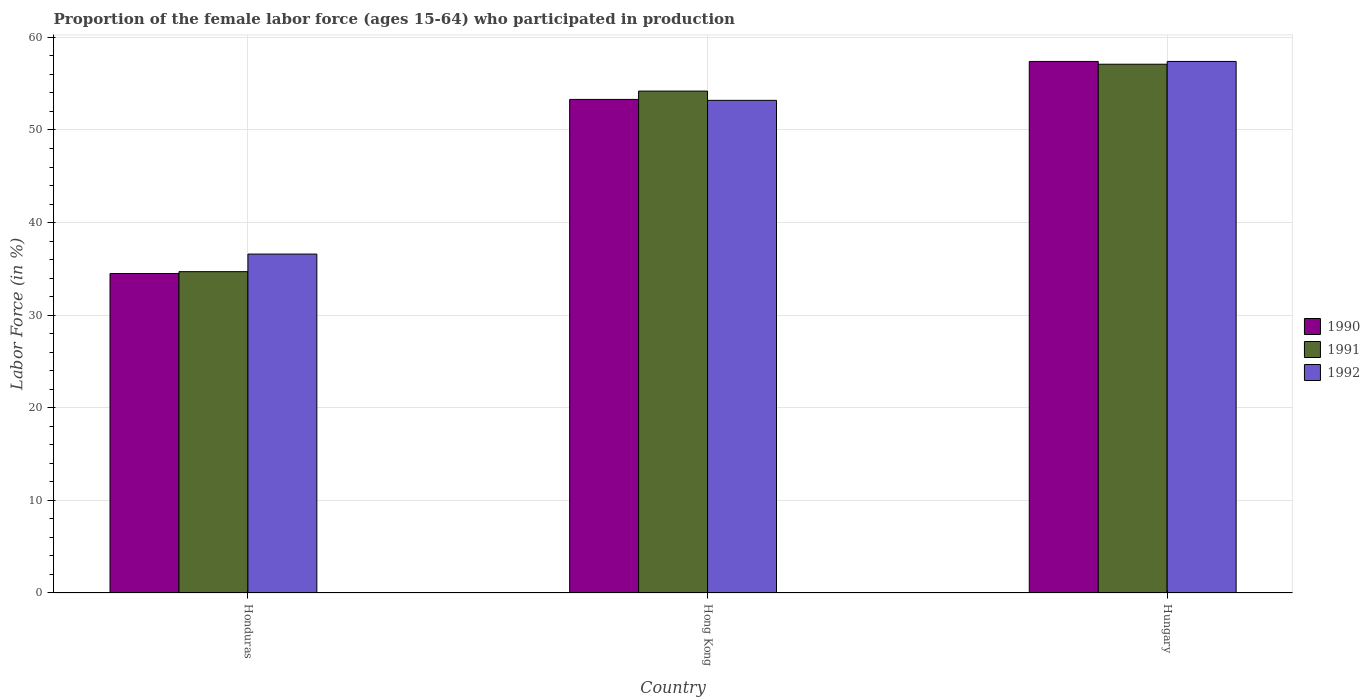How many different coloured bars are there?
Your answer should be very brief. 3. How many groups of bars are there?
Provide a succinct answer. 3. Are the number of bars per tick equal to the number of legend labels?
Your response must be concise. Yes. Are the number of bars on each tick of the X-axis equal?
Ensure brevity in your answer.  Yes. What is the label of the 3rd group of bars from the left?
Keep it short and to the point. Hungary. In how many cases, is the number of bars for a given country not equal to the number of legend labels?
Keep it short and to the point. 0. What is the proportion of the female labor force who participated in production in 1991 in Hong Kong?
Provide a succinct answer. 54.2. Across all countries, what is the maximum proportion of the female labor force who participated in production in 1990?
Offer a very short reply. 57.4. Across all countries, what is the minimum proportion of the female labor force who participated in production in 1992?
Your answer should be very brief. 36.6. In which country was the proportion of the female labor force who participated in production in 1992 maximum?
Make the answer very short. Hungary. In which country was the proportion of the female labor force who participated in production in 1990 minimum?
Make the answer very short. Honduras. What is the total proportion of the female labor force who participated in production in 1990 in the graph?
Offer a terse response. 145.2. What is the difference between the proportion of the female labor force who participated in production in 1991 in Honduras and that in Hungary?
Ensure brevity in your answer.  -22.4. What is the difference between the proportion of the female labor force who participated in production in 1990 in Hong Kong and the proportion of the female labor force who participated in production in 1991 in Honduras?
Offer a very short reply. 18.6. What is the average proportion of the female labor force who participated in production in 1990 per country?
Your answer should be compact. 48.4. What is the difference between the proportion of the female labor force who participated in production of/in 1990 and proportion of the female labor force who participated in production of/in 1992 in Honduras?
Your answer should be very brief. -2.1. What is the ratio of the proportion of the female labor force who participated in production in 1990 in Honduras to that in Hungary?
Make the answer very short. 0.6. Is the difference between the proportion of the female labor force who participated in production in 1990 in Hong Kong and Hungary greater than the difference between the proportion of the female labor force who participated in production in 1992 in Hong Kong and Hungary?
Offer a terse response. Yes. What is the difference between the highest and the second highest proportion of the female labor force who participated in production in 1992?
Give a very brief answer. 20.8. What is the difference between the highest and the lowest proportion of the female labor force who participated in production in 1990?
Offer a terse response. 22.9. Is the sum of the proportion of the female labor force who participated in production in 1991 in Hong Kong and Hungary greater than the maximum proportion of the female labor force who participated in production in 1990 across all countries?
Offer a terse response. Yes. Is it the case that in every country, the sum of the proportion of the female labor force who participated in production in 1992 and proportion of the female labor force who participated in production in 1991 is greater than the proportion of the female labor force who participated in production in 1990?
Keep it short and to the point. Yes. How many countries are there in the graph?
Offer a terse response. 3. What is the difference between two consecutive major ticks on the Y-axis?
Offer a terse response. 10. Does the graph contain any zero values?
Keep it short and to the point. No. Does the graph contain grids?
Offer a terse response. Yes. How many legend labels are there?
Give a very brief answer. 3. What is the title of the graph?
Keep it short and to the point. Proportion of the female labor force (ages 15-64) who participated in production. Does "2007" appear as one of the legend labels in the graph?
Provide a short and direct response. No. What is the label or title of the Y-axis?
Give a very brief answer. Labor Force (in %). What is the Labor Force (in %) in 1990 in Honduras?
Provide a short and direct response. 34.5. What is the Labor Force (in %) of 1991 in Honduras?
Give a very brief answer. 34.7. What is the Labor Force (in %) in 1992 in Honduras?
Keep it short and to the point. 36.6. What is the Labor Force (in %) of 1990 in Hong Kong?
Your answer should be compact. 53.3. What is the Labor Force (in %) of 1991 in Hong Kong?
Offer a terse response. 54.2. What is the Labor Force (in %) in 1992 in Hong Kong?
Make the answer very short. 53.2. What is the Labor Force (in %) of 1990 in Hungary?
Make the answer very short. 57.4. What is the Labor Force (in %) in 1991 in Hungary?
Offer a terse response. 57.1. What is the Labor Force (in %) of 1992 in Hungary?
Offer a very short reply. 57.4. Across all countries, what is the maximum Labor Force (in %) of 1990?
Keep it short and to the point. 57.4. Across all countries, what is the maximum Labor Force (in %) in 1991?
Ensure brevity in your answer.  57.1. Across all countries, what is the maximum Labor Force (in %) in 1992?
Offer a terse response. 57.4. Across all countries, what is the minimum Labor Force (in %) of 1990?
Keep it short and to the point. 34.5. Across all countries, what is the minimum Labor Force (in %) of 1991?
Provide a succinct answer. 34.7. Across all countries, what is the minimum Labor Force (in %) in 1992?
Your response must be concise. 36.6. What is the total Labor Force (in %) of 1990 in the graph?
Offer a very short reply. 145.2. What is the total Labor Force (in %) of 1991 in the graph?
Your answer should be very brief. 146. What is the total Labor Force (in %) in 1992 in the graph?
Your response must be concise. 147.2. What is the difference between the Labor Force (in %) in 1990 in Honduras and that in Hong Kong?
Your answer should be very brief. -18.8. What is the difference between the Labor Force (in %) of 1991 in Honduras and that in Hong Kong?
Make the answer very short. -19.5. What is the difference between the Labor Force (in %) in 1992 in Honduras and that in Hong Kong?
Give a very brief answer. -16.6. What is the difference between the Labor Force (in %) in 1990 in Honduras and that in Hungary?
Make the answer very short. -22.9. What is the difference between the Labor Force (in %) of 1991 in Honduras and that in Hungary?
Keep it short and to the point. -22.4. What is the difference between the Labor Force (in %) of 1992 in Honduras and that in Hungary?
Your answer should be compact. -20.8. What is the difference between the Labor Force (in %) of 1991 in Hong Kong and that in Hungary?
Provide a succinct answer. -2.9. What is the difference between the Labor Force (in %) in 1990 in Honduras and the Labor Force (in %) in 1991 in Hong Kong?
Ensure brevity in your answer.  -19.7. What is the difference between the Labor Force (in %) of 1990 in Honduras and the Labor Force (in %) of 1992 in Hong Kong?
Offer a very short reply. -18.7. What is the difference between the Labor Force (in %) of 1991 in Honduras and the Labor Force (in %) of 1992 in Hong Kong?
Give a very brief answer. -18.5. What is the difference between the Labor Force (in %) of 1990 in Honduras and the Labor Force (in %) of 1991 in Hungary?
Keep it short and to the point. -22.6. What is the difference between the Labor Force (in %) of 1990 in Honduras and the Labor Force (in %) of 1992 in Hungary?
Your response must be concise. -22.9. What is the difference between the Labor Force (in %) of 1991 in Honduras and the Labor Force (in %) of 1992 in Hungary?
Ensure brevity in your answer.  -22.7. What is the difference between the Labor Force (in %) of 1991 in Hong Kong and the Labor Force (in %) of 1992 in Hungary?
Provide a short and direct response. -3.2. What is the average Labor Force (in %) of 1990 per country?
Offer a terse response. 48.4. What is the average Labor Force (in %) in 1991 per country?
Provide a short and direct response. 48.67. What is the average Labor Force (in %) in 1992 per country?
Your answer should be compact. 49.07. What is the difference between the Labor Force (in %) in 1990 and Labor Force (in %) in 1992 in Honduras?
Your answer should be very brief. -2.1. What is the difference between the Labor Force (in %) in 1991 and Labor Force (in %) in 1992 in Honduras?
Your answer should be very brief. -1.9. What is the difference between the Labor Force (in %) in 1990 and Labor Force (in %) in 1992 in Hong Kong?
Ensure brevity in your answer.  0.1. What is the difference between the Labor Force (in %) of 1990 and Labor Force (in %) of 1992 in Hungary?
Your response must be concise. 0. What is the difference between the Labor Force (in %) in 1991 and Labor Force (in %) in 1992 in Hungary?
Your answer should be very brief. -0.3. What is the ratio of the Labor Force (in %) of 1990 in Honduras to that in Hong Kong?
Keep it short and to the point. 0.65. What is the ratio of the Labor Force (in %) in 1991 in Honduras to that in Hong Kong?
Make the answer very short. 0.64. What is the ratio of the Labor Force (in %) in 1992 in Honduras to that in Hong Kong?
Give a very brief answer. 0.69. What is the ratio of the Labor Force (in %) in 1990 in Honduras to that in Hungary?
Provide a short and direct response. 0.6. What is the ratio of the Labor Force (in %) of 1991 in Honduras to that in Hungary?
Offer a very short reply. 0.61. What is the ratio of the Labor Force (in %) of 1992 in Honduras to that in Hungary?
Your answer should be very brief. 0.64. What is the ratio of the Labor Force (in %) of 1990 in Hong Kong to that in Hungary?
Offer a very short reply. 0.93. What is the ratio of the Labor Force (in %) in 1991 in Hong Kong to that in Hungary?
Keep it short and to the point. 0.95. What is the ratio of the Labor Force (in %) of 1992 in Hong Kong to that in Hungary?
Provide a succinct answer. 0.93. What is the difference between the highest and the second highest Labor Force (in %) of 1991?
Your answer should be very brief. 2.9. What is the difference between the highest and the second highest Labor Force (in %) of 1992?
Your response must be concise. 4.2. What is the difference between the highest and the lowest Labor Force (in %) of 1990?
Make the answer very short. 22.9. What is the difference between the highest and the lowest Labor Force (in %) of 1991?
Give a very brief answer. 22.4. What is the difference between the highest and the lowest Labor Force (in %) in 1992?
Your response must be concise. 20.8. 